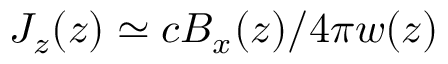Convert formula to latex. <formula><loc_0><loc_0><loc_500><loc_500>J _ { z } ( z ) \simeq c B _ { x } ( z ) / 4 \pi w ( z )</formula> 